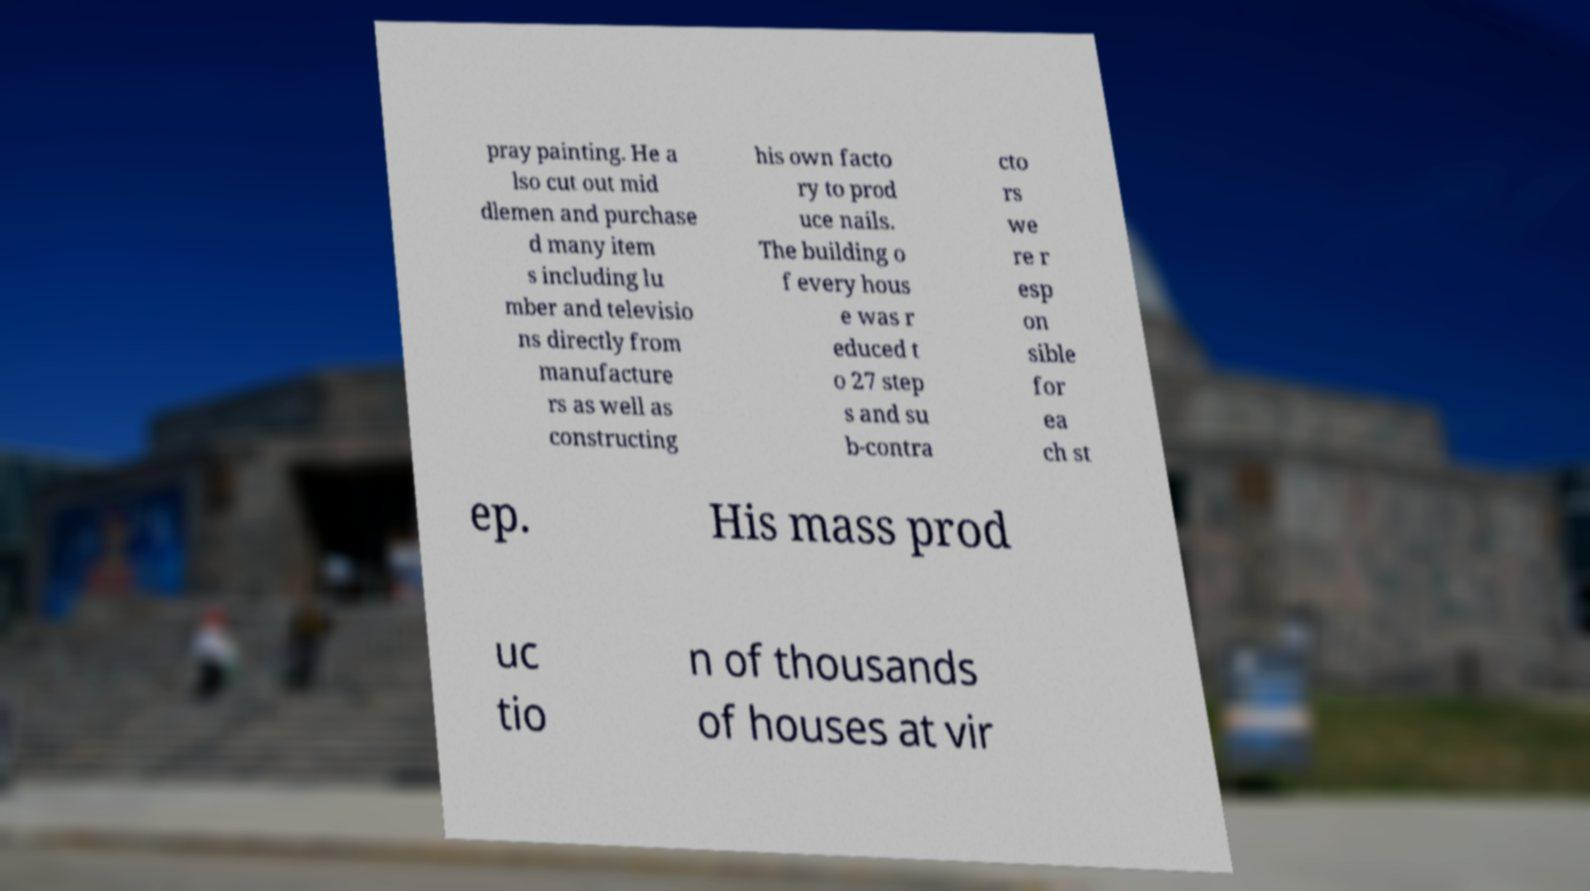For documentation purposes, I need the text within this image transcribed. Could you provide that? pray painting. He a lso cut out mid dlemen and purchase d many item s including lu mber and televisio ns directly from manufacture rs as well as constructing his own facto ry to prod uce nails. The building o f every hous e was r educed t o 27 step s and su b-contra cto rs we re r esp on sible for ea ch st ep. His mass prod uc tio n of thousands of houses at vir 